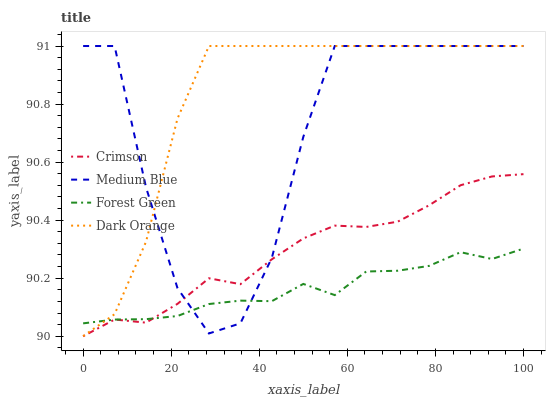Does Dark Orange have the minimum area under the curve?
Answer yes or no. No. Does Forest Green have the maximum area under the curve?
Answer yes or no. No. Is Dark Orange the smoothest?
Answer yes or no. No. Is Dark Orange the roughest?
Answer yes or no. No. Does Dark Orange have the lowest value?
Answer yes or no. No. Does Forest Green have the highest value?
Answer yes or no. No. Is Crimson less than Dark Orange?
Answer yes or no. Yes. Is Dark Orange greater than Crimson?
Answer yes or no. Yes. Does Crimson intersect Dark Orange?
Answer yes or no. No. 